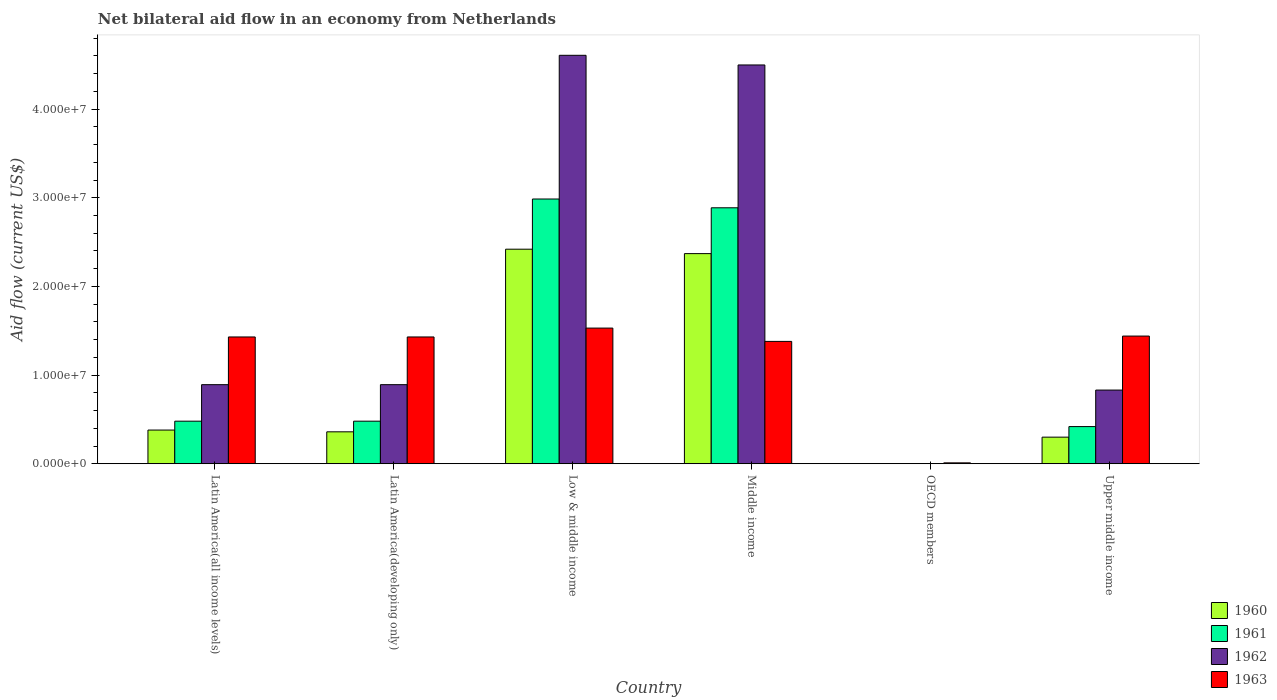How many different coloured bars are there?
Your response must be concise. 4. Are the number of bars per tick equal to the number of legend labels?
Provide a succinct answer. No. Are the number of bars on each tick of the X-axis equal?
Ensure brevity in your answer.  No. What is the label of the 4th group of bars from the left?
Your answer should be very brief. Middle income. In how many cases, is the number of bars for a given country not equal to the number of legend labels?
Offer a terse response. 1. What is the net bilateral aid flow in 1963 in Upper middle income?
Your answer should be very brief. 1.44e+07. Across all countries, what is the maximum net bilateral aid flow in 1962?
Offer a very short reply. 4.61e+07. Across all countries, what is the minimum net bilateral aid flow in 1963?
Keep it short and to the point. 1.00e+05. What is the total net bilateral aid flow in 1960 in the graph?
Offer a terse response. 5.83e+07. What is the difference between the net bilateral aid flow in 1962 in Low & middle income and that in Middle income?
Your answer should be compact. 1.09e+06. What is the difference between the net bilateral aid flow in 1961 in OECD members and the net bilateral aid flow in 1963 in Middle income?
Offer a very short reply. -1.38e+07. What is the average net bilateral aid flow in 1961 per country?
Give a very brief answer. 1.21e+07. What is the difference between the net bilateral aid flow of/in 1963 and net bilateral aid flow of/in 1961 in Latin America(all income levels)?
Provide a short and direct response. 9.50e+06. What is the ratio of the net bilateral aid flow in 1963 in Latin America(all income levels) to that in Upper middle income?
Your response must be concise. 0.99. What is the difference between the highest and the lowest net bilateral aid flow in 1963?
Offer a terse response. 1.52e+07. Is the sum of the net bilateral aid flow in 1960 in Middle income and Upper middle income greater than the maximum net bilateral aid flow in 1962 across all countries?
Offer a very short reply. No. How many bars are there?
Your answer should be compact. 21. Are all the bars in the graph horizontal?
Your answer should be very brief. No. How many countries are there in the graph?
Offer a very short reply. 6. What is the difference between two consecutive major ticks on the Y-axis?
Provide a short and direct response. 1.00e+07. Does the graph contain any zero values?
Provide a succinct answer. Yes. How many legend labels are there?
Ensure brevity in your answer.  4. What is the title of the graph?
Offer a terse response. Net bilateral aid flow in an economy from Netherlands. What is the label or title of the X-axis?
Your answer should be compact. Country. What is the label or title of the Y-axis?
Offer a terse response. Aid flow (current US$). What is the Aid flow (current US$) in 1960 in Latin America(all income levels)?
Provide a short and direct response. 3.80e+06. What is the Aid flow (current US$) of 1961 in Latin America(all income levels)?
Offer a terse response. 4.80e+06. What is the Aid flow (current US$) in 1962 in Latin America(all income levels)?
Offer a very short reply. 8.92e+06. What is the Aid flow (current US$) in 1963 in Latin America(all income levels)?
Offer a very short reply. 1.43e+07. What is the Aid flow (current US$) of 1960 in Latin America(developing only)?
Provide a short and direct response. 3.60e+06. What is the Aid flow (current US$) of 1961 in Latin America(developing only)?
Provide a succinct answer. 4.80e+06. What is the Aid flow (current US$) of 1962 in Latin America(developing only)?
Offer a terse response. 8.92e+06. What is the Aid flow (current US$) in 1963 in Latin America(developing only)?
Your response must be concise. 1.43e+07. What is the Aid flow (current US$) in 1960 in Low & middle income?
Offer a terse response. 2.42e+07. What is the Aid flow (current US$) of 1961 in Low & middle income?
Your response must be concise. 2.99e+07. What is the Aid flow (current US$) in 1962 in Low & middle income?
Your answer should be very brief. 4.61e+07. What is the Aid flow (current US$) in 1963 in Low & middle income?
Provide a short and direct response. 1.53e+07. What is the Aid flow (current US$) of 1960 in Middle income?
Provide a short and direct response. 2.37e+07. What is the Aid flow (current US$) in 1961 in Middle income?
Make the answer very short. 2.89e+07. What is the Aid flow (current US$) in 1962 in Middle income?
Give a very brief answer. 4.50e+07. What is the Aid flow (current US$) in 1963 in Middle income?
Your answer should be very brief. 1.38e+07. What is the Aid flow (current US$) of 1961 in OECD members?
Ensure brevity in your answer.  0. What is the Aid flow (current US$) of 1963 in OECD members?
Your answer should be very brief. 1.00e+05. What is the Aid flow (current US$) in 1960 in Upper middle income?
Your answer should be compact. 3.00e+06. What is the Aid flow (current US$) in 1961 in Upper middle income?
Provide a short and direct response. 4.19e+06. What is the Aid flow (current US$) of 1962 in Upper middle income?
Your answer should be very brief. 8.31e+06. What is the Aid flow (current US$) in 1963 in Upper middle income?
Offer a terse response. 1.44e+07. Across all countries, what is the maximum Aid flow (current US$) in 1960?
Provide a short and direct response. 2.42e+07. Across all countries, what is the maximum Aid flow (current US$) in 1961?
Your answer should be very brief. 2.99e+07. Across all countries, what is the maximum Aid flow (current US$) in 1962?
Make the answer very short. 4.61e+07. Across all countries, what is the maximum Aid flow (current US$) of 1963?
Your answer should be compact. 1.53e+07. Across all countries, what is the minimum Aid flow (current US$) in 1961?
Your answer should be compact. 0. What is the total Aid flow (current US$) in 1960 in the graph?
Give a very brief answer. 5.83e+07. What is the total Aid flow (current US$) of 1961 in the graph?
Your answer should be compact. 7.25e+07. What is the total Aid flow (current US$) of 1962 in the graph?
Make the answer very short. 1.17e+08. What is the total Aid flow (current US$) in 1963 in the graph?
Offer a very short reply. 7.22e+07. What is the difference between the Aid flow (current US$) of 1960 in Latin America(all income levels) and that in Latin America(developing only)?
Provide a succinct answer. 2.00e+05. What is the difference between the Aid flow (current US$) of 1961 in Latin America(all income levels) and that in Latin America(developing only)?
Offer a terse response. 0. What is the difference between the Aid flow (current US$) of 1960 in Latin America(all income levels) and that in Low & middle income?
Ensure brevity in your answer.  -2.04e+07. What is the difference between the Aid flow (current US$) of 1961 in Latin America(all income levels) and that in Low & middle income?
Keep it short and to the point. -2.51e+07. What is the difference between the Aid flow (current US$) of 1962 in Latin America(all income levels) and that in Low & middle income?
Provide a succinct answer. -3.72e+07. What is the difference between the Aid flow (current US$) of 1960 in Latin America(all income levels) and that in Middle income?
Ensure brevity in your answer.  -1.99e+07. What is the difference between the Aid flow (current US$) in 1961 in Latin America(all income levels) and that in Middle income?
Give a very brief answer. -2.41e+07. What is the difference between the Aid flow (current US$) in 1962 in Latin America(all income levels) and that in Middle income?
Make the answer very short. -3.61e+07. What is the difference between the Aid flow (current US$) of 1963 in Latin America(all income levels) and that in OECD members?
Ensure brevity in your answer.  1.42e+07. What is the difference between the Aid flow (current US$) of 1960 in Latin America(all income levels) and that in Upper middle income?
Offer a very short reply. 8.00e+05. What is the difference between the Aid flow (current US$) in 1963 in Latin America(all income levels) and that in Upper middle income?
Your answer should be very brief. -1.00e+05. What is the difference between the Aid flow (current US$) of 1960 in Latin America(developing only) and that in Low & middle income?
Give a very brief answer. -2.06e+07. What is the difference between the Aid flow (current US$) of 1961 in Latin America(developing only) and that in Low & middle income?
Offer a terse response. -2.51e+07. What is the difference between the Aid flow (current US$) in 1962 in Latin America(developing only) and that in Low & middle income?
Provide a succinct answer. -3.72e+07. What is the difference between the Aid flow (current US$) in 1960 in Latin America(developing only) and that in Middle income?
Offer a terse response. -2.01e+07. What is the difference between the Aid flow (current US$) in 1961 in Latin America(developing only) and that in Middle income?
Your answer should be very brief. -2.41e+07. What is the difference between the Aid flow (current US$) of 1962 in Latin America(developing only) and that in Middle income?
Offer a terse response. -3.61e+07. What is the difference between the Aid flow (current US$) of 1963 in Latin America(developing only) and that in OECD members?
Keep it short and to the point. 1.42e+07. What is the difference between the Aid flow (current US$) in 1960 in Latin America(developing only) and that in Upper middle income?
Give a very brief answer. 6.00e+05. What is the difference between the Aid flow (current US$) in 1962 in Latin America(developing only) and that in Upper middle income?
Offer a very short reply. 6.10e+05. What is the difference between the Aid flow (current US$) in 1961 in Low & middle income and that in Middle income?
Keep it short and to the point. 9.90e+05. What is the difference between the Aid flow (current US$) in 1962 in Low & middle income and that in Middle income?
Provide a succinct answer. 1.09e+06. What is the difference between the Aid flow (current US$) in 1963 in Low & middle income and that in Middle income?
Your answer should be compact. 1.50e+06. What is the difference between the Aid flow (current US$) of 1963 in Low & middle income and that in OECD members?
Your response must be concise. 1.52e+07. What is the difference between the Aid flow (current US$) in 1960 in Low & middle income and that in Upper middle income?
Offer a very short reply. 2.12e+07. What is the difference between the Aid flow (current US$) in 1961 in Low & middle income and that in Upper middle income?
Give a very brief answer. 2.57e+07. What is the difference between the Aid flow (current US$) of 1962 in Low & middle income and that in Upper middle income?
Provide a succinct answer. 3.78e+07. What is the difference between the Aid flow (current US$) in 1963 in Middle income and that in OECD members?
Offer a very short reply. 1.37e+07. What is the difference between the Aid flow (current US$) in 1960 in Middle income and that in Upper middle income?
Your response must be concise. 2.07e+07. What is the difference between the Aid flow (current US$) in 1961 in Middle income and that in Upper middle income?
Give a very brief answer. 2.47e+07. What is the difference between the Aid flow (current US$) of 1962 in Middle income and that in Upper middle income?
Your answer should be very brief. 3.67e+07. What is the difference between the Aid flow (current US$) of 1963 in Middle income and that in Upper middle income?
Provide a short and direct response. -6.00e+05. What is the difference between the Aid flow (current US$) in 1963 in OECD members and that in Upper middle income?
Ensure brevity in your answer.  -1.43e+07. What is the difference between the Aid flow (current US$) in 1960 in Latin America(all income levels) and the Aid flow (current US$) in 1962 in Latin America(developing only)?
Your answer should be very brief. -5.12e+06. What is the difference between the Aid flow (current US$) in 1960 in Latin America(all income levels) and the Aid flow (current US$) in 1963 in Latin America(developing only)?
Provide a short and direct response. -1.05e+07. What is the difference between the Aid flow (current US$) in 1961 in Latin America(all income levels) and the Aid flow (current US$) in 1962 in Latin America(developing only)?
Provide a short and direct response. -4.12e+06. What is the difference between the Aid flow (current US$) of 1961 in Latin America(all income levels) and the Aid flow (current US$) of 1963 in Latin America(developing only)?
Your response must be concise. -9.50e+06. What is the difference between the Aid flow (current US$) in 1962 in Latin America(all income levels) and the Aid flow (current US$) in 1963 in Latin America(developing only)?
Make the answer very short. -5.38e+06. What is the difference between the Aid flow (current US$) of 1960 in Latin America(all income levels) and the Aid flow (current US$) of 1961 in Low & middle income?
Offer a very short reply. -2.61e+07. What is the difference between the Aid flow (current US$) in 1960 in Latin America(all income levels) and the Aid flow (current US$) in 1962 in Low & middle income?
Provide a short and direct response. -4.23e+07. What is the difference between the Aid flow (current US$) in 1960 in Latin America(all income levels) and the Aid flow (current US$) in 1963 in Low & middle income?
Your answer should be very brief. -1.15e+07. What is the difference between the Aid flow (current US$) of 1961 in Latin America(all income levels) and the Aid flow (current US$) of 1962 in Low & middle income?
Ensure brevity in your answer.  -4.13e+07. What is the difference between the Aid flow (current US$) of 1961 in Latin America(all income levels) and the Aid flow (current US$) of 1963 in Low & middle income?
Provide a succinct answer. -1.05e+07. What is the difference between the Aid flow (current US$) in 1962 in Latin America(all income levels) and the Aid flow (current US$) in 1963 in Low & middle income?
Keep it short and to the point. -6.38e+06. What is the difference between the Aid flow (current US$) in 1960 in Latin America(all income levels) and the Aid flow (current US$) in 1961 in Middle income?
Give a very brief answer. -2.51e+07. What is the difference between the Aid flow (current US$) of 1960 in Latin America(all income levels) and the Aid flow (current US$) of 1962 in Middle income?
Keep it short and to the point. -4.12e+07. What is the difference between the Aid flow (current US$) in 1960 in Latin America(all income levels) and the Aid flow (current US$) in 1963 in Middle income?
Provide a short and direct response. -1.00e+07. What is the difference between the Aid flow (current US$) of 1961 in Latin America(all income levels) and the Aid flow (current US$) of 1962 in Middle income?
Provide a short and direct response. -4.02e+07. What is the difference between the Aid flow (current US$) of 1961 in Latin America(all income levels) and the Aid flow (current US$) of 1963 in Middle income?
Keep it short and to the point. -9.00e+06. What is the difference between the Aid flow (current US$) of 1962 in Latin America(all income levels) and the Aid flow (current US$) of 1963 in Middle income?
Your answer should be compact. -4.88e+06. What is the difference between the Aid flow (current US$) in 1960 in Latin America(all income levels) and the Aid flow (current US$) in 1963 in OECD members?
Keep it short and to the point. 3.70e+06. What is the difference between the Aid flow (current US$) in 1961 in Latin America(all income levels) and the Aid flow (current US$) in 1963 in OECD members?
Your response must be concise. 4.70e+06. What is the difference between the Aid flow (current US$) of 1962 in Latin America(all income levels) and the Aid flow (current US$) of 1963 in OECD members?
Your answer should be very brief. 8.82e+06. What is the difference between the Aid flow (current US$) in 1960 in Latin America(all income levels) and the Aid flow (current US$) in 1961 in Upper middle income?
Your answer should be very brief. -3.90e+05. What is the difference between the Aid flow (current US$) in 1960 in Latin America(all income levels) and the Aid flow (current US$) in 1962 in Upper middle income?
Your answer should be very brief. -4.51e+06. What is the difference between the Aid flow (current US$) of 1960 in Latin America(all income levels) and the Aid flow (current US$) of 1963 in Upper middle income?
Ensure brevity in your answer.  -1.06e+07. What is the difference between the Aid flow (current US$) in 1961 in Latin America(all income levels) and the Aid flow (current US$) in 1962 in Upper middle income?
Make the answer very short. -3.51e+06. What is the difference between the Aid flow (current US$) in 1961 in Latin America(all income levels) and the Aid flow (current US$) in 1963 in Upper middle income?
Your answer should be very brief. -9.60e+06. What is the difference between the Aid flow (current US$) in 1962 in Latin America(all income levels) and the Aid flow (current US$) in 1963 in Upper middle income?
Provide a short and direct response. -5.48e+06. What is the difference between the Aid flow (current US$) of 1960 in Latin America(developing only) and the Aid flow (current US$) of 1961 in Low & middle income?
Make the answer very short. -2.63e+07. What is the difference between the Aid flow (current US$) in 1960 in Latin America(developing only) and the Aid flow (current US$) in 1962 in Low & middle income?
Your response must be concise. -4.25e+07. What is the difference between the Aid flow (current US$) of 1960 in Latin America(developing only) and the Aid flow (current US$) of 1963 in Low & middle income?
Your response must be concise. -1.17e+07. What is the difference between the Aid flow (current US$) of 1961 in Latin America(developing only) and the Aid flow (current US$) of 1962 in Low & middle income?
Give a very brief answer. -4.13e+07. What is the difference between the Aid flow (current US$) of 1961 in Latin America(developing only) and the Aid flow (current US$) of 1963 in Low & middle income?
Make the answer very short. -1.05e+07. What is the difference between the Aid flow (current US$) in 1962 in Latin America(developing only) and the Aid flow (current US$) in 1963 in Low & middle income?
Provide a short and direct response. -6.38e+06. What is the difference between the Aid flow (current US$) of 1960 in Latin America(developing only) and the Aid flow (current US$) of 1961 in Middle income?
Offer a very short reply. -2.53e+07. What is the difference between the Aid flow (current US$) in 1960 in Latin America(developing only) and the Aid flow (current US$) in 1962 in Middle income?
Your response must be concise. -4.14e+07. What is the difference between the Aid flow (current US$) in 1960 in Latin America(developing only) and the Aid flow (current US$) in 1963 in Middle income?
Your answer should be compact. -1.02e+07. What is the difference between the Aid flow (current US$) in 1961 in Latin America(developing only) and the Aid flow (current US$) in 1962 in Middle income?
Provide a succinct answer. -4.02e+07. What is the difference between the Aid flow (current US$) in 1961 in Latin America(developing only) and the Aid flow (current US$) in 1963 in Middle income?
Your response must be concise. -9.00e+06. What is the difference between the Aid flow (current US$) in 1962 in Latin America(developing only) and the Aid flow (current US$) in 1963 in Middle income?
Give a very brief answer. -4.88e+06. What is the difference between the Aid flow (current US$) of 1960 in Latin America(developing only) and the Aid flow (current US$) of 1963 in OECD members?
Offer a very short reply. 3.50e+06. What is the difference between the Aid flow (current US$) of 1961 in Latin America(developing only) and the Aid flow (current US$) of 1963 in OECD members?
Provide a short and direct response. 4.70e+06. What is the difference between the Aid flow (current US$) in 1962 in Latin America(developing only) and the Aid flow (current US$) in 1963 in OECD members?
Keep it short and to the point. 8.82e+06. What is the difference between the Aid flow (current US$) of 1960 in Latin America(developing only) and the Aid flow (current US$) of 1961 in Upper middle income?
Your answer should be very brief. -5.90e+05. What is the difference between the Aid flow (current US$) in 1960 in Latin America(developing only) and the Aid flow (current US$) in 1962 in Upper middle income?
Provide a succinct answer. -4.71e+06. What is the difference between the Aid flow (current US$) of 1960 in Latin America(developing only) and the Aid flow (current US$) of 1963 in Upper middle income?
Provide a succinct answer. -1.08e+07. What is the difference between the Aid flow (current US$) in 1961 in Latin America(developing only) and the Aid flow (current US$) in 1962 in Upper middle income?
Your answer should be very brief. -3.51e+06. What is the difference between the Aid flow (current US$) of 1961 in Latin America(developing only) and the Aid flow (current US$) of 1963 in Upper middle income?
Make the answer very short. -9.60e+06. What is the difference between the Aid flow (current US$) of 1962 in Latin America(developing only) and the Aid flow (current US$) of 1963 in Upper middle income?
Offer a very short reply. -5.48e+06. What is the difference between the Aid flow (current US$) of 1960 in Low & middle income and the Aid flow (current US$) of 1961 in Middle income?
Make the answer very short. -4.67e+06. What is the difference between the Aid flow (current US$) in 1960 in Low & middle income and the Aid flow (current US$) in 1962 in Middle income?
Your response must be concise. -2.08e+07. What is the difference between the Aid flow (current US$) of 1960 in Low & middle income and the Aid flow (current US$) of 1963 in Middle income?
Give a very brief answer. 1.04e+07. What is the difference between the Aid flow (current US$) in 1961 in Low & middle income and the Aid flow (current US$) in 1962 in Middle income?
Keep it short and to the point. -1.51e+07. What is the difference between the Aid flow (current US$) in 1961 in Low & middle income and the Aid flow (current US$) in 1963 in Middle income?
Your response must be concise. 1.61e+07. What is the difference between the Aid flow (current US$) of 1962 in Low & middle income and the Aid flow (current US$) of 1963 in Middle income?
Your response must be concise. 3.23e+07. What is the difference between the Aid flow (current US$) of 1960 in Low & middle income and the Aid flow (current US$) of 1963 in OECD members?
Provide a succinct answer. 2.41e+07. What is the difference between the Aid flow (current US$) in 1961 in Low & middle income and the Aid flow (current US$) in 1963 in OECD members?
Your answer should be very brief. 2.98e+07. What is the difference between the Aid flow (current US$) in 1962 in Low & middle income and the Aid flow (current US$) in 1963 in OECD members?
Your answer should be compact. 4.60e+07. What is the difference between the Aid flow (current US$) in 1960 in Low & middle income and the Aid flow (current US$) in 1961 in Upper middle income?
Provide a short and direct response. 2.00e+07. What is the difference between the Aid flow (current US$) of 1960 in Low & middle income and the Aid flow (current US$) of 1962 in Upper middle income?
Your answer should be very brief. 1.59e+07. What is the difference between the Aid flow (current US$) in 1960 in Low & middle income and the Aid flow (current US$) in 1963 in Upper middle income?
Offer a very short reply. 9.80e+06. What is the difference between the Aid flow (current US$) in 1961 in Low & middle income and the Aid flow (current US$) in 1962 in Upper middle income?
Give a very brief answer. 2.16e+07. What is the difference between the Aid flow (current US$) in 1961 in Low & middle income and the Aid flow (current US$) in 1963 in Upper middle income?
Provide a succinct answer. 1.55e+07. What is the difference between the Aid flow (current US$) in 1962 in Low & middle income and the Aid flow (current US$) in 1963 in Upper middle income?
Your response must be concise. 3.17e+07. What is the difference between the Aid flow (current US$) of 1960 in Middle income and the Aid flow (current US$) of 1963 in OECD members?
Ensure brevity in your answer.  2.36e+07. What is the difference between the Aid flow (current US$) of 1961 in Middle income and the Aid flow (current US$) of 1963 in OECD members?
Make the answer very short. 2.88e+07. What is the difference between the Aid flow (current US$) in 1962 in Middle income and the Aid flow (current US$) in 1963 in OECD members?
Your answer should be very brief. 4.49e+07. What is the difference between the Aid flow (current US$) of 1960 in Middle income and the Aid flow (current US$) of 1961 in Upper middle income?
Your response must be concise. 1.95e+07. What is the difference between the Aid flow (current US$) of 1960 in Middle income and the Aid flow (current US$) of 1962 in Upper middle income?
Keep it short and to the point. 1.54e+07. What is the difference between the Aid flow (current US$) of 1960 in Middle income and the Aid flow (current US$) of 1963 in Upper middle income?
Your response must be concise. 9.30e+06. What is the difference between the Aid flow (current US$) of 1961 in Middle income and the Aid flow (current US$) of 1962 in Upper middle income?
Offer a terse response. 2.06e+07. What is the difference between the Aid flow (current US$) in 1961 in Middle income and the Aid flow (current US$) in 1963 in Upper middle income?
Make the answer very short. 1.45e+07. What is the difference between the Aid flow (current US$) of 1962 in Middle income and the Aid flow (current US$) of 1963 in Upper middle income?
Offer a very short reply. 3.06e+07. What is the average Aid flow (current US$) in 1960 per country?
Provide a succinct answer. 9.72e+06. What is the average Aid flow (current US$) of 1961 per country?
Provide a succinct answer. 1.21e+07. What is the average Aid flow (current US$) in 1962 per country?
Offer a very short reply. 1.95e+07. What is the average Aid flow (current US$) in 1963 per country?
Offer a very short reply. 1.20e+07. What is the difference between the Aid flow (current US$) of 1960 and Aid flow (current US$) of 1962 in Latin America(all income levels)?
Offer a terse response. -5.12e+06. What is the difference between the Aid flow (current US$) in 1960 and Aid flow (current US$) in 1963 in Latin America(all income levels)?
Offer a very short reply. -1.05e+07. What is the difference between the Aid flow (current US$) in 1961 and Aid flow (current US$) in 1962 in Latin America(all income levels)?
Your response must be concise. -4.12e+06. What is the difference between the Aid flow (current US$) of 1961 and Aid flow (current US$) of 1963 in Latin America(all income levels)?
Provide a short and direct response. -9.50e+06. What is the difference between the Aid flow (current US$) of 1962 and Aid flow (current US$) of 1963 in Latin America(all income levels)?
Offer a very short reply. -5.38e+06. What is the difference between the Aid flow (current US$) in 1960 and Aid flow (current US$) in 1961 in Latin America(developing only)?
Provide a short and direct response. -1.20e+06. What is the difference between the Aid flow (current US$) of 1960 and Aid flow (current US$) of 1962 in Latin America(developing only)?
Make the answer very short. -5.32e+06. What is the difference between the Aid flow (current US$) of 1960 and Aid flow (current US$) of 1963 in Latin America(developing only)?
Provide a short and direct response. -1.07e+07. What is the difference between the Aid flow (current US$) in 1961 and Aid flow (current US$) in 1962 in Latin America(developing only)?
Ensure brevity in your answer.  -4.12e+06. What is the difference between the Aid flow (current US$) of 1961 and Aid flow (current US$) of 1963 in Latin America(developing only)?
Your response must be concise. -9.50e+06. What is the difference between the Aid flow (current US$) of 1962 and Aid flow (current US$) of 1963 in Latin America(developing only)?
Ensure brevity in your answer.  -5.38e+06. What is the difference between the Aid flow (current US$) in 1960 and Aid flow (current US$) in 1961 in Low & middle income?
Ensure brevity in your answer.  -5.66e+06. What is the difference between the Aid flow (current US$) in 1960 and Aid flow (current US$) in 1962 in Low & middle income?
Give a very brief answer. -2.19e+07. What is the difference between the Aid flow (current US$) in 1960 and Aid flow (current US$) in 1963 in Low & middle income?
Provide a succinct answer. 8.90e+06. What is the difference between the Aid flow (current US$) in 1961 and Aid flow (current US$) in 1962 in Low & middle income?
Provide a succinct answer. -1.62e+07. What is the difference between the Aid flow (current US$) in 1961 and Aid flow (current US$) in 1963 in Low & middle income?
Give a very brief answer. 1.46e+07. What is the difference between the Aid flow (current US$) of 1962 and Aid flow (current US$) of 1963 in Low & middle income?
Ensure brevity in your answer.  3.08e+07. What is the difference between the Aid flow (current US$) of 1960 and Aid flow (current US$) of 1961 in Middle income?
Keep it short and to the point. -5.17e+06. What is the difference between the Aid flow (current US$) of 1960 and Aid flow (current US$) of 1962 in Middle income?
Your response must be concise. -2.13e+07. What is the difference between the Aid flow (current US$) in 1960 and Aid flow (current US$) in 1963 in Middle income?
Keep it short and to the point. 9.90e+06. What is the difference between the Aid flow (current US$) of 1961 and Aid flow (current US$) of 1962 in Middle income?
Make the answer very short. -1.61e+07. What is the difference between the Aid flow (current US$) of 1961 and Aid flow (current US$) of 1963 in Middle income?
Make the answer very short. 1.51e+07. What is the difference between the Aid flow (current US$) in 1962 and Aid flow (current US$) in 1963 in Middle income?
Provide a short and direct response. 3.12e+07. What is the difference between the Aid flow (current US$) of 1960 and Aid flow (current US$) of 1961 in Upper middle income?
Your answer should be compact. -1.19e+06. What is the difference between the Aid flow (current US$) of 1960 and Aid flow (current US$) of 1962 in Upper middle income?
Your response must be concise. -5.31e+06. What is the difference between the Aid flow (current US$) in 1960 and Aid flow (current US$) in 1963 in Upper middle income?
Keep it short and to the point. -1.14e+07. What is the difference between the Aid flow (current US$) of 1961 and Aid flow (current US$) of 1962 in Upper middle income?
Give a very brief answer. -4.12e+06. What is the difference between the Aid flow (current US$) in 1961 and Aid flow (current US$) in 1963 in Upper middle income?
Provide a short and direct response. -1.02e+07. What is the difference between the Aid flow (current US$) in 1962 and Aid flow (current US$) in 1963 in Upper middle income?
Your response must be concise. -6.09e+06. What is the ratio of the Aid flow (current US$) in 1960 in Latin America(all income levels) to that in Latin America(developing only)?
Ensure brevity in your answer.  1.06. What is the ratio of the Aid flow (current US$) in 1962 in Latin America(all income levels) to that in Latin America(developing only)?
Keep it short and to the point. 1. What is the ratio of the Aid flow (current US$) in 1963 in Latin America(all income levels) to that in Latin America(developing only)?
Make the answer very short. 1. What is the ratio of the Aid flow (current US$) of 1960 in Latin America(all income levels) to that in Low & middle income?
Your response must be concise. 0.16. What is the ratio of the Aid flow (current US$) of 1961 in Latin America(all income levels) to that in Low & middle income?
Give a very brief answer. 0.16. What is the ratio of the Aid flow (current US$) in 1962 in Latin America(all income levels) to that in Low & middle income?
Ensure brevity in your answer.  0.19. What is the ratio of the Aid flow (current US$) of 1963 in Latin America(all income levels) to that in Low & middle income?
Make the answer very short. 0.93. What is the ratio of the Aid flow (current US$) in 1960 in Latin America(all income levels) to that in Middle income?
Give a very brief answer. 0.16. What is the ratio of the Aid flow (current US$) of 1961 in Latin America(all income levels) to that in Middle income?
Give a very brief answer. 0.17. What is the ratio of the Aid flow (current US$) in 1962 in Latin America(all income levels) to that in Middle income?
Make the answer very short. 0.2. What is the ratio of the Aid flow (current US$) of 1963 in Latin America(all income levels) to that in Middle income?
Give a very brief answer. 1.04. What is the ratio of the Aid flow (current US$) of 1963 in Latin America(all income levels) to that in OECD members?
Provide a short and direct response. 143. What is the ratio of the Aid flow (current US$) in 1960 in Latin America(all income levels) to that in Upper middle income?
Keep it short and to the point. 1.27. What is the ratio of the Aid flow (current US$) in 1961 in Latin America(all income levels) to that in Upper middle income?
Make the answer very short. 1.15. What is the ratio of the Aid flow (current US$) of 1962 in Latin America(all income levels) to that in Upper middle income?
Provide a short and direct response. 1.07. What is the ratio of the Aid flow (current US$) of 1963 in Latin America(all income levels) to that in Upper middle income?
Make the answer very short. 0.99. What is the ratio of the Aid flow (current US$) of 1960 in Latin America(developing only) to that in Low & middle income?
Make the answer very short. 0.15. What is the ratio of the Aid flow (current US$) in 1961 in Latin America(developing only) to that in Low & middle income?
Make the answer very short. 0.16. What is the ratio of the Aid flow (current US$) in 1962 in Latin America(developing only) to that in Low & middle income?
Your answer should be very brief. 0.19. What is the ratio of the Aid flow (current US$) of 1963 in Latin America(developing only) to that in Low & middle income?
Offer a terse response. 0.93. What is the ratio of the Aid flow (current US$) in 1960 in Latin America(developing only) to that in Middle income?
Offer a very short reply. 0.15. What is the ratio of the Aid flow (current US$) of 1961 in Latin America(developing only) to that in Middle income?
Make the answer very short. 0.17. What is the ratio of the Aid flow (current US$) in 1962 in Latin America(developing only) to that in Middle income?
Keep it short and to the point. 0.2. What is the ratio of the Aid flow (current US$) in 1963 in Latin America(developing only) to that in Middle income?
Make the answer very short. 1.04. What is the ratio of the Aid flow (current US$) of 1963 in Latin America(developing only) to that in OECD members?
Make the answer very short. 143. What is the ratio of the Aid flow (current US$) of 1960 in Latin America(developing only) to that in Upper middle income?
Provide a succinct answer. 1.2. What is the ratio of the Aid flow (current US$) in 1961 in Latin America(developing only) to that in Upper middle income?
Provide a short and direct response. 1.15. What is the ratio of the Aid flow (current US$) in 1962 in Latin America(developing only) to that in Upper middle income?
Your response must be concise. 1.07. What is the ratio of the Aid flow (current US$) of 1963 in Latin America(developing only) to that in Upper middle income?
Offer a terse response. 0.99. What is the ratio of the Aid flow (current US$) in 1960 in Low & middle income to that in Middle income?
Your answer should be compact. 1.02. What is the ratio of the Aid flow (current US$) in 1961 in Low & middle income to that in Middle income?
Your response must be concise. 1.03. What is the ratio of the Aid flow (current US$) of 1962 in Low & middle income to that in Middle income?
Your answer should be compact. 1.02. What is the ratio of the Aid flow (current US$) in 1963 in Low & middle income to that in Middle income?
Provide a short and direct response. 1.11. What is the ratio of the Aid flow (current US$) of 1963 in Low & middle income to that in OECD members?
Give a very brief answer. 153. What is the ratio of the Aid flow (current US$) in 1960 in Low & middle income to that in Upper middle income?
Provide a succinct answer. 8.07. What is the ratio of the Aid flow (current US$) in 1961 in Low & middle income to that in Upper middle income?
Your answer should be very brief. 7.13. What is the ratio of the Aid flow (current US$) of 1962 in Low & middle income to that in Upper middle income?
Your answer should be very brief. 5.54. What is the ratio of the Aid flow (current US$) of 1963 in Low & middle income to that in Upper middle income?
Keep it short and to the point. 1.06. What is the ratio of the Aid flow (current US$) in 1963 in Middle income to that in OECD members?
Give a very brief answer. 138. What is the ratio of the Aid flow (current US$) in 1961 in Middle income to that in Upper middle income?
Ensure brevity in your answer.  6.89. What is the ratio of the Aid flow (current US$) of 1962 in Middle income to that in Upper middle income?
Provide a short and direct response. 5.41. What is the ratio of the Aid flow (current US$) in 1963 in OECD members to that in Upper middle income?
Keep it short and to the point. 0.01. What is the difference between the highest and the second highest Aid flow (current US$) in 1961?
Ensure brevity in your answer.  9.90e+05. What is the difference between the highest and the second highest Aid flow (current US$) of 1962?
Keep it short and to the point. 1.09e+06. What is the difference between the highest and the second highest Aid flow (current US$) in 1963?
Ensure brevity in your answer.  9.00e+05. What is the difference between the highest and the lowest Aid flow (current US$) in 1960?
Your answer should be compact. 2.42e+07. What is the difference between the highest and the lowest Aid flow (current US$) of 1961?
Your answer should be very brief. 2.99e+07. What is the difference between the highest and the lowest Aid flow (current US$) in 1962?
Your response must be concise. 4.61e+07. What is the difference between the highest and the lowest Aid flow (current US$) in 1963?
Your response must be concise. 1.52e+07. 